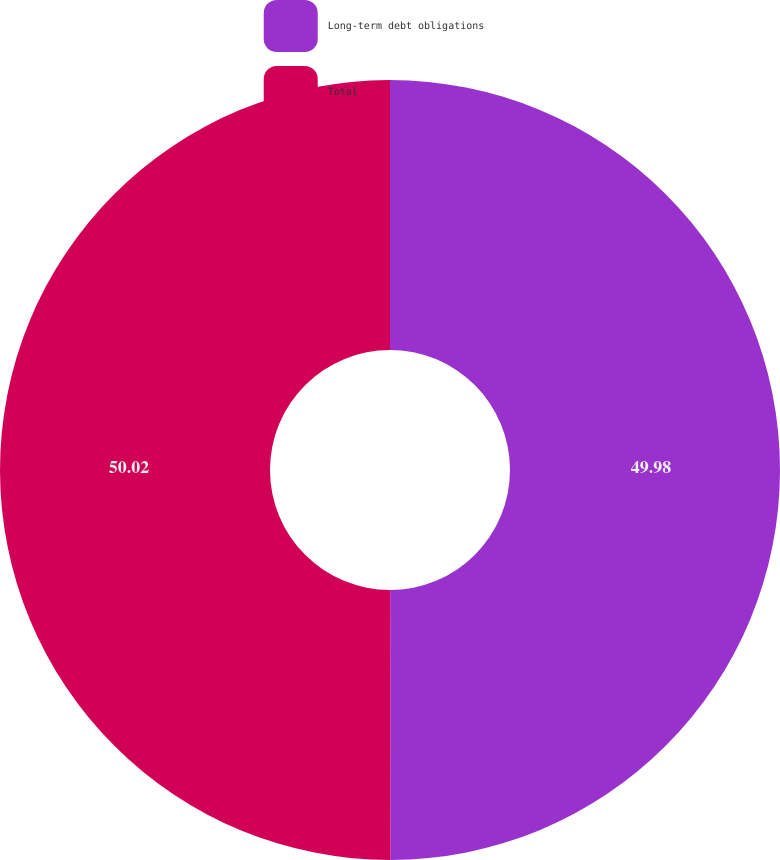Convert chart to OTSL. <chart><loc_0><loc_0><loc_500><loc_500><pie_chart><fcel>Long-term debt obligations<fcel>Total<nl><fcel>49.98%<fcel>50.02%<nl></chart> 